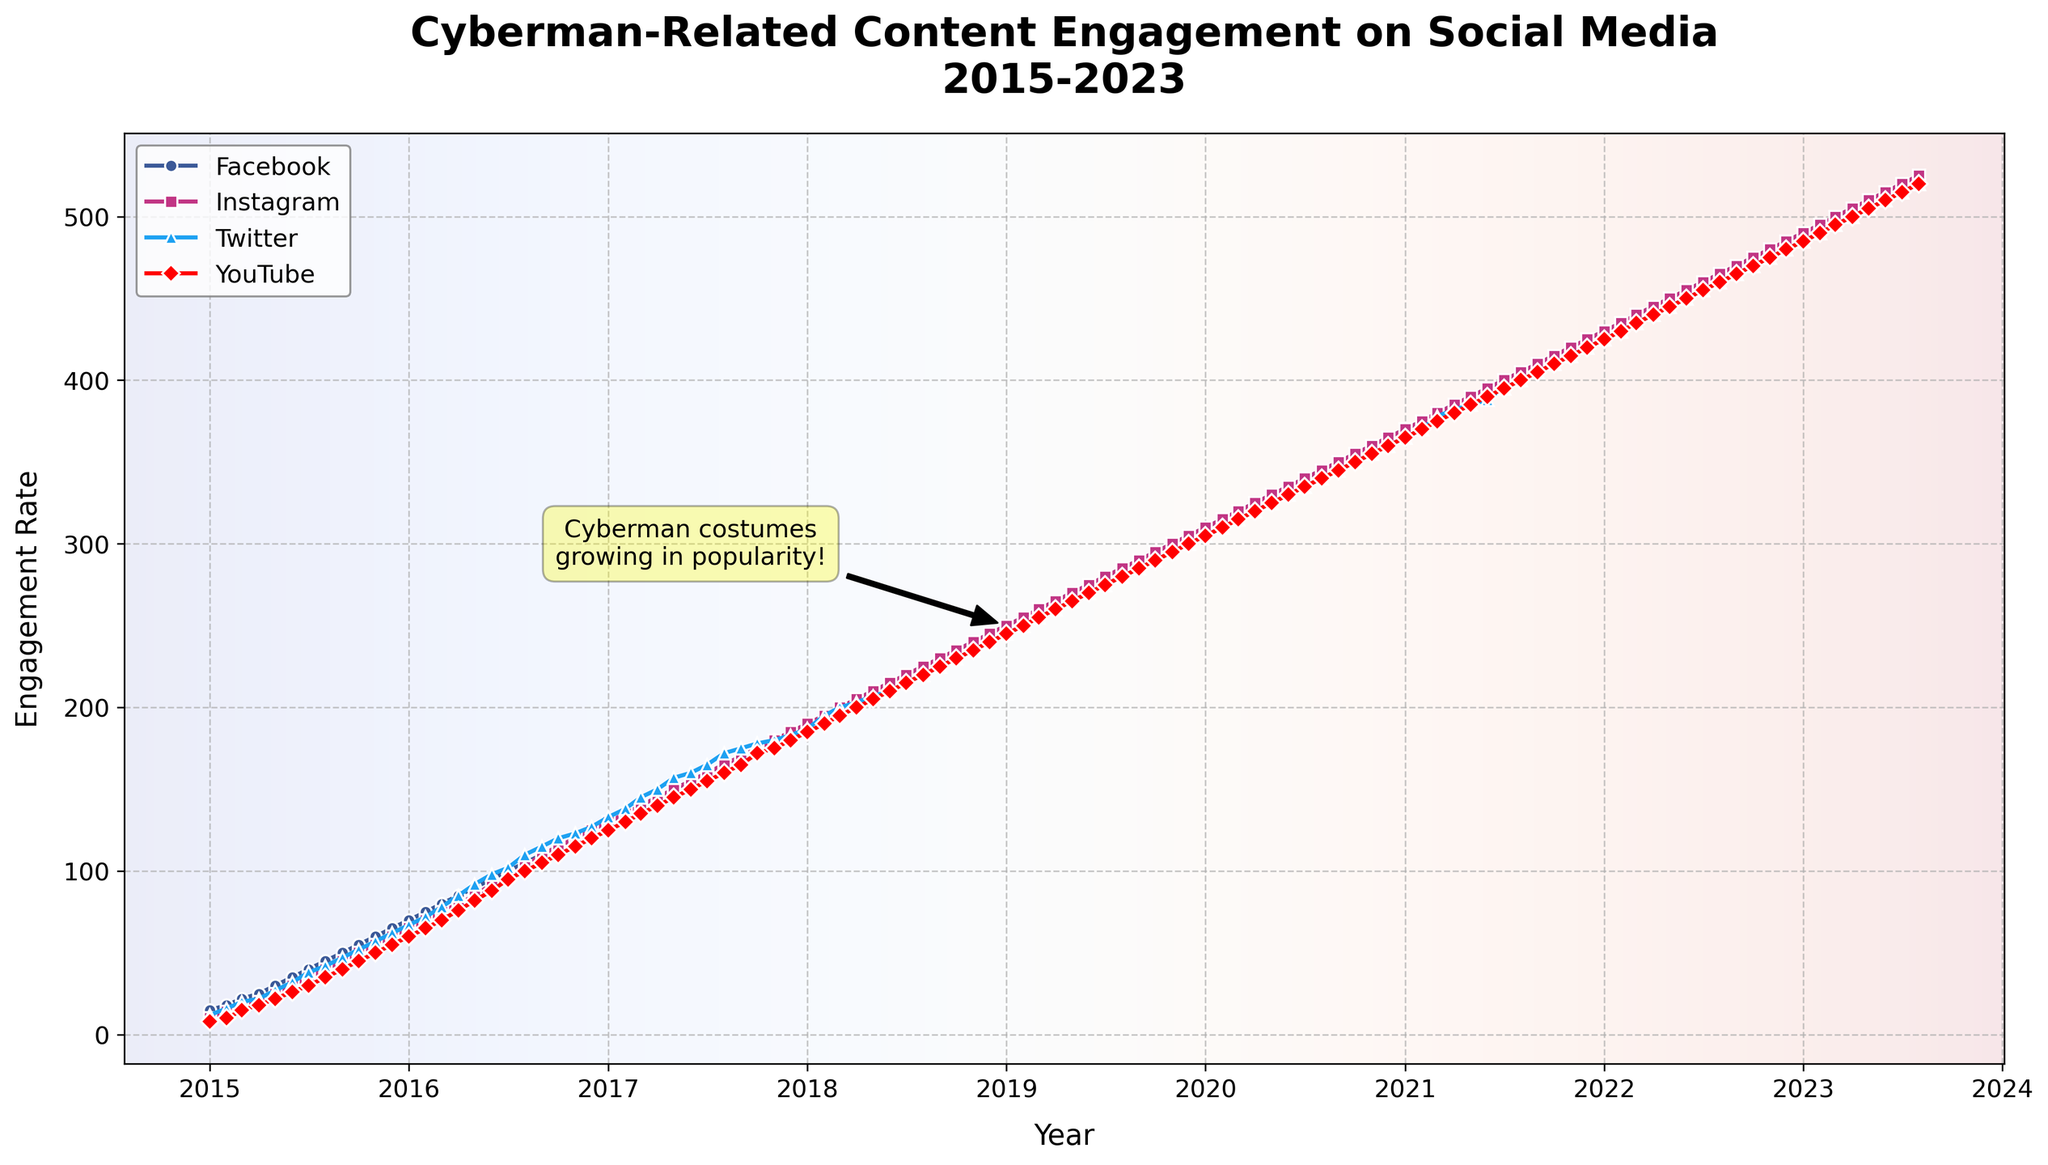What's the title of the figure? The title of the figure is a direct annotation on the top part of the plot. It reads "Cyberman-Related Content Engagement on Social Media\n2015-2023".
Answer: Cyberman-Related Content Engagement on Social Media\n2015-2023 What period does the x-axis cover? The x-axis starts from January 2015 and ends at August 2023. These dates can be seen at the beginning and end of the x-axis.
Answer: January 2015 to August 2023 Which social media platform showed the highest engagement rate in August 2023? By looking at the rightmost data points for August 2023, the platform with the highest engagement rate is YouTube, as indicated by the highest point on the y-axis.
Answer: YouTube Which social media engagement rate was the lowest in January 2020? Checking the data points at January 2020, YouTube has the lowest engagement rate among the platforms listed in the plot.
Answer: YouTube How did Facebook engagement rates change from January 2016 to January 2017? By looking at the data points for January 2016 and January 2017 on the plot line for Facebook, the engagement rates increased from 70 to 130. The difference is 130 - 70 = 60.
Answer: Increased by 60 What was the difference in Instagram engagement rates between June 2020 and June 2021? From the data points at June 2020 and June 2021, Instagram engagement rates were 335 and 395, respectively. The difference is 395 - 335 = 60.
Answer: 60 Which platform had the most consistent growth from 2015 to 2023? Observing the slope and smoothness of the lines, Facebook seems to have the most consistent growth, with a steady increase in engagement rates over the period.
Answer: Facebook What is the average engagement rate for Twitter in 2019? In 2019, the engagement rates for Twitter by month are: 245, 250, 255, 260, 265, 270, 275, 280, 285, 290, 295, 300. Sum these values and divide by 12 to find the average: (245 + 250 + 255 + 260 + 265 + 270 + 275 + 280 + 285 + 290 + 295 + 300) / 12 = 273.75.
Answer: 273.75 How did YouTube engagement rates change between January 2018 and December 2022? From January 2018 to December 2022, YouTube engagement rates increased from 185 to 480. The change is calculated as 480 - 185 = 295.
Answer: Increased by 295 Which year showed the highest increase in Instagram engagement rates? To determine the highest annual increase, observe the differences between January of one year to January of the next year. The highest increase is from January 2017 (130) to January 2018 (190), which is an increase of 60.
Answer: 2017 to 2018 